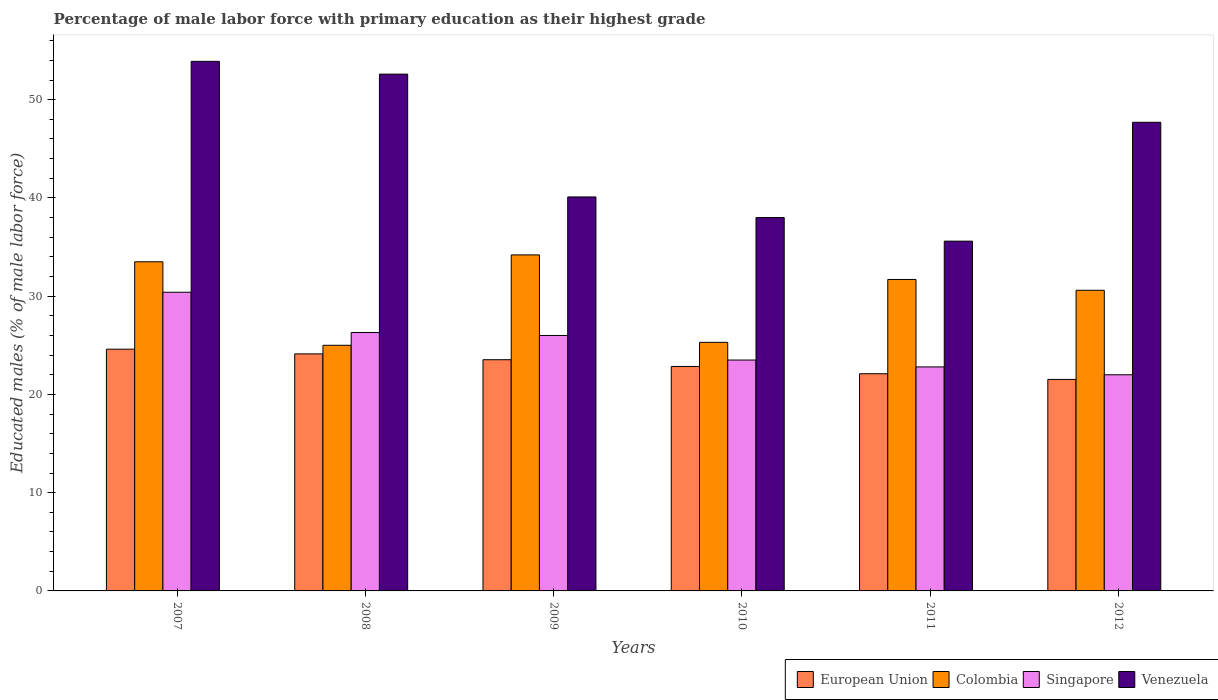How many different coloured bars are there?
Keep it short and to the point. 4. Are the number of bars per tick equal to the number of legend labels?
Give a very brief answer. Yes. Are the number of bars on each tick of the X-axis equal?
Your response must be concise. Yes. In how many cases, is the number of bars for a given year not equal to the number of legend labels?
Your answer should be very brief. 0. What is the percentage of male labor force with primary education in European Union in 2012?
Your answer should be very brief. 21.53. Across all years, what is the maximum percentage of male labor force with primary education in Singapore?
Your answer should be compact. 30.4. In which year was the percentage of male labor force with primary education in Colombia maximum?
Ensure brevity in your answer.  2009. In which year was the percentage of male labor force with primary education in European Union minimum?
Your response must be concise. 2012. What is the total percentage of male labor force with primary education in Venezuela in the graph?
Offer a terse response. 267.9. What is the difference between the percentage of male labor force with primary education in Colombia in 2008 and the percentage of male labor force with primary education in Venezuela in 2012?
Your response must be concise. -22.7. What is the average percentage of male labor force with primary education in Colombia per year?
Your answer should be compact. 30.05. In the year 2008, what is the difference between the percentage of male labor force with primary education in Venezuela and percentage of male labor force with primary education in European Union?
Give a very brief answer. 28.47. In how many years, is the percentage of male labor force with primary education in Singapore greater than 40 %?
Your answer should be very brief. 0. What is the ratio of the percentage of male labor force with primary education in Singapore in 2007 to that in 2012?
Offer a very short reply. 1.38. Is the percentage of male labor force with primary education in Singapore in 2010 less than that in 2012?
Make the answer very short. No. What is the difference between the highest and the second highest percentage of male labor force with primary education in European Union?
Provide a succinct answer. 0.48. What is the difference between the highest and the lowest percentage of male labor force with primary education in Venezuela?
Make the answer very short. 18.3. In how many years, is the percentage of male labor force with primary education in European Union greater than the average percentage of male labor force with primary education in European Union taken over all years?
Your answer should be very brief. 3. What does the 4th bar from the left in 2007 represents?
Provide a short and direct response. Venezuela. What does the 1st bar from the right in 2009 represents?
Provide a short and direct response. Venezuela. Does the graph contain any zero values?
Ensure brevity in your answer.  No. Where does the legend appear in the graph?
Keep it short and to the point. Bottom right. What is the title of the graph?
Make the answer very short. Percentage of male labor force with primary education as their highest grade. Does "Grenada" appear as one of the legend labels in the graph?
Your answer should be very brief. No. What is the label or title of the X-axis?
Offer a terse response. Years. What is the label or title of the Y-axis?
Provide a short and direct response. Educated males (% of male labor force). What is the Educated males (% of male labor force) of European Union in 2007?
Keep it short and to the point. 24.61. What is the Educated males (% of male labor force) in Colombia in 2007?
Keep it short and to the point. 33.5. What is the Educated males (% of male labor force) of Singapore in 2007?
Your answer should be compact. 30.4. What is the Educated males (% of male labor force) in Venezuela in 2007?
Keep it short and to the point. 53.9. What is the Educated males (% of male labor force) in European Union in 2008?
Keep it short and to the point. 24.13. What is the Educated males (% of male labor force) of Colombia in 2008?
Provide a short and direct response. 25. What is the Educated males (% of male labor force) in Singapore in 2008?
Offer a very short reply. 26.3. What is the Educated males (% of male labor force) of Venezuela in 2008?
Keep it short and to the point. 52.6. What is the Educated males (% of male labor force) in European Union in 2009?
Provide a succinct answer. 23.53. What is the Educated males (% of male labor force) in Colombia in 2009?
Provide a succinct answer. 34.2. What is the Educated males (% of male labor force) of Venezuela in 2009?
Your response must be concise. 40.1. What is the Educated males (% of male labor force) of European Union in 2010?
Make the answer very short. 22.85. What is the Educated males (% of male labor force) in Colombia in 2010?
Ensure brevity in your answer.  25.3. What is the Educated males (% of male labor force) in European Union in 2011?
Your response must be concise. 22.11. What is the Educated males (% of male labor force) of Colombia in 2011?
Provide a short and direct response. 31.7. What is the Educated males (% of male labor force) in Singapore in 2011?
Offer a terse response. 22.8. What is the Educated males (% of male labor force) in Venezuela in 2011?
Your answer should be very brief. 35.6. What is the Educated males (% of male labor force) in European Union in 2012?
Ensure brevity in your answer.  21.53. What is the Educated males (% of male labor force) of Colombia in 2012?
Offer a very short reply. 30.6. What is the Educated males (% of male labor force) of Singapore in 2012?
Your answer should be very brief. 22. What is the Educated males (% of male labor force) in Venezuela in 2012?
Your response must be concise. 47.7. Across all years, what is the maximum Educated males (% of male labor force) in European Union?
Your response must be concise. 24.61. Across all years, what is the maximum Educated males (% of male labor force) of Colombia?
Provide a short and direct response. 34.2. Across all years, what is the maximum Educated males (% of male labor force) of Singapore?
Keep it short and to the point. 30.4. Across all years, what is the maximum Educated males (% of male labor force) in Venezuela?
Offer a terse response. 53.9. Across all years, what is the minimum Educated males (% of male labor force) in European Union?
Your answer should be very brief. 21.53. Across all years, what is the minimum Educated males (% of male labor force) of Colombia?
Provide a succinct answer. 25. Across all years, what is the minimum Educated males (% of male labor force) of Singapore?
Your answer should be compact. 22. Across all years, what is the minimum Educated males (% of male labor force) of Venezuela?
Keep it short and to the point. 35.6. What is the total Educated males (% of male labor force) in European Union in the graph?
Your answer should be compact. 138.74. What is the total Educated males (% of male labor force) in Colombia in the graph?
Your response must be concise. 180.3. What is the total Educated males (% of male labor force) in Singapore in the graph?
Your answer should be compact. 151. What is the total Educated males (% of male labor force) of Venezuela in the graph?
Provide a succinct answer. 267.9. What is the difference between the Educated males (% of male labor force) in European Union in 2007 and that in 2008?
Give a very brief answer. 0.48. What is the difference between the Educated males (% of male labor force) of Singapore in 2007 and that in 2008?
Your answer should be very brief. 4.1. What is the difference between the Educated males (% of male labor force) in Venezuela in 2007 and that in 2008?
Offer a very short reply. 1.3. What is the difference between the Educated males (% of male labor force) of European Union in 2007 and that in 2009?
Offer a terse response. 1.07. What is the difference between the Educated males (% of male labor force) in Colombia in 2007 and that in 2009?
Your answer should be compact. -0.7. What is the difference between the Educated males (% of male labor force) of Venezuela in 2007 and that in 2009?
Provide a short and direct response. 13.8. What is the difference between the Educated males (% of male labor force) in European Union in 2007 and that in 2010?
Your answer should be very brief. 1.76. What is the difference between the Educated males (% of male labor force) of Colombia in 2007 and that in 2010?
Keep it short and to the point. 8.2. What is the difference between the Educated males (% of male labor force) in Venezuela in 2007 and that in 2010?
Your answer should be very brief. 15.9. What is the difference between the Educated males (% of male labor force) in European Union in 2007 and that in 2011?
Ensure brevity in your answer.  2.5. What is the difference between the Educated males (% of male labor force) in Singapore in 2007 and that in 2011?
Offer a very short reply. 7.6. What is the difference between the Educated males (% of male labor force) of European Union in 2007 and that in 2012?
Offer a very short reply. 3.08. What is the difference between the Educated males (% of male labor force) in Singapore in 2007 and that in 2012?
Keep it short and to the point. 8.4. What is the difference between the Educated males (% of male labor force) of Venezuela in 2007 and that in 2012?
Offer a very short reply. 6.2. What is the difference between the Educated males (% of male labor force) of European Union in 2008 and that in 2009?
Ensure brevity in your answer.  0.59. What is the difference between the Educated males (% of male labor force) in Colombia in 2008 and that in 2009?
Ensure brevity in your answer.  -9.2. What is the difference between the Educated males (% of male labor force) in Singapore in 2008 and that in 2009?
Provide a succinct answer. 0.3. What is the difference between the Educated males (% of male labor force) of European Union in 2008 and that in 2010?
Offer a terse response. 1.28. What is the difference between the Educated males (% of male labor force) in Singapore in 2008 and that in 2010?
Your response must be concise. 2.8. What is the difference between the Educated males (% of male labor force) in European Union in 2008 and that in 2011?
Provide a succinct answer. 2.02. What is the difference between the Educated males (% of male labor force) in Colombia in 2008 and that in 2011?
Your response must be concise. -6.7. What is the difference between the Educated males (% of male labor force) of Venezuela in 2008 and that in 2011?
Offer a terse response. 17. What is the difference between the Educated males (% of male labor force) in European Union in 2008 and that in 2012?
Ensure brevity in your answer.  2.6. What is the difference between the Educated males (% of male labor force) of Singapore in 2008 and that in 2012?
Ensure brevity in your answer.  4.3. What is the difference between the Educated males (% of male labor force) in Venezuela in 2008 and that in 2012?
Make the answer very short. 4.9. What is the difference between the Educated males (% of male labor force) of European Union in 2009 and that in 2010?
Your answer should be compact. 0.69. What is the difference between the Educated males (% of male labor force) of Singapore in 2009 and that in 2010?
Provide a short and direct response. 2.5. What is the difference between the Educated males (% of male labor force) in Venezuela in 2009 and that in 2010?
Offer a terse response. 2.1. What is the difference between the Educated males (% of male labor force) of European Union in 2009 and that in 2011?
Your response must be concise. 1.43. What is the difference between the Educated males (% of male labor force) of Singapore in 2009 and that in 2011?
Give a very brief answer. 3.2. What is the difference between the Educated males (% of male labor force) in Venezuela in 2009 and that in 2011?
Your answer should be compact. 4.5. What is the difference between the Educated males (% of male labor force) in European Union in 2009 and that in 2012?
Ensure brevity in your answer.  2.01. What is the difference between the Educated males (% of male labor force) of Colombia in 2009 and that in 2012?
Provide a short and direct response. 3.6. What is the difference between the Educated males (% of male labor force) of Venezuela in 2009 and that in 2012?
Offer a very short reply. -7.6. What is the difference between the Educated males (% of male labor force) in European Union in 2010 and that in 2011?
Give a very brief answer. 0.74. What is the difference between the Educated males (% of male labor force) of Singapore in 2010 and that in 2011?
Offer a terse response. 0.7. What is the difference between the Educated males (% of male labor force) of European Union in 2010 and that in 2012?
Make the answer very short. 1.32. What is the difference between the Educated males (% of male labor force) of Colombia in 2010 and that in 2012?
Give a very brief answer. -5.3. What is the difference between the Educated males (% of male labor force) in Singapore in 2010 and that in 2012?
Give a very brief answer. 1.5. What is the difference between the Educated males (% of male labor force) of Venezuela in 2010 and that in 2012?
Offer a very short reply. -9.7. What is the difference between the Educated males (% of male labor force) in European Union in 2011 and that in 2012?
Ensure brevity in your answer.  0.58. What is the difference between the Educated males (% of male labor force) of European Union in 2007 and the Educated males (% of male labor force) of Colombia in 2008?
Ensure brevity in your answer.  -0.39. What is the difference between the Educated males (% of male labor force) in European Union in 2007 and the Educated males (% of male labor force) in Singapore in 2008?
Provide a short and direct response. -1.69. What is the difference between the Educated males (% of male labor force) in European Union in 2007 and the Educated males (% of male labor force) in Venezuela in 2008?
Your answer should be very brief. -27.99. What is the difference between the Educated males (% of male labor force) in Colombia in 2007 and the Educated males (% of male labor force) in Venezuela in 2008?
Provide a succinct answer. -19.1. What is the difference between the Educated males (% of male labor force) in Singapore in 2007 and the Educated males (% of male labor force) in Venezuela in 2008?
Your answer should be compact. -22.2. What is the difference between the Educated males (% of male labor force) of European Union in 2007 and the Educated males (% of male labor force) of Colombia in 2009?
Your answer should be compact. -9.59. What is the difference between the Educated males (% of male labor force) of European Union in 2007 and the Educated males (% of male labor force) of Singapore in 2009?
Keep it short and to the point. -1.39. What is the difference between the Educated males (% of male labor force) in European Union in 2007 and the Educated males (% of male labor force) in Venezuela in 2009?
Offer a very short reply. -15.49. What is the difference between the Educated males (% of male labor force) of Colombia in 2007 and the Educated males (% of male labor force) of Venezuela in 2009?
Your answer should be very brief. -6.6. What is the difference between the Educated males (% of male labor force) in Singapore in 2007 and the Educated males (% of male labor force) in Venezuela in 2009?
Offer a very short reply. -9.7. What is the difference between the Educated males (% of male labor force) of European Union in 2007 and the Educated males (% of male labor force) of Colombia in 2010?
Provide a short and direct response. -0.69. What is the difference between the Educated males (% of male labor force) of European Union in 2007 and the Educated males (% of male labor force) of Singapore in 2010?
Ensure brevity in your answer.  1.11. What is the difference between the Educated males (% of male labor force) of European Union in 2007 and the Educated males (% of male labor force) of Venezuela in 2010?
Offer a terse response. -13.39. What is the difference between the Educated males (% of male labor force) of Colombia in 2007 and the Educated males (% of male labor force) of Singapore in 2010?
Provide a succinct answer. 10. What is the difference between the Educated males (% of male labor force) in Colombia in 2007 and the Educated males (% of male labor force) in Venezuela in 2010?
Provide a short and direct response. -4.5. What is the difference between the Educated males (% of male labor force) in European Union in 2007 and the Educated males (% of male labor force) in Colombia in 2011?
Your answer should be compact. -7.09. What is the difference between the Educated males (% of male labor force) in European Union in 2007 and the Educated males (% of male labor force) in Singapore in 2011?
Your answer should be compact. 1.81. What is the difference between the Educated males (% of male labor force) of European Union in 2007 and the Educated males (% of male labor force) of Venezuela in 2011?
Your answer should be compact. -10.99. What is the difference between the Educated males (% of male labor force) of Colombia in 2007 and the Educated males (% of male labor force) of Singapore in 2011?
Give a very brief answer. 10.7. What is the difference between the Educated males (% of male labor force) in Colombia in 2007 and the Educated males (% of male labor force) in Venezuela in 2011?
Ensure brevity in your answer.  -2.1. What is the difference between the Educated males (% of male labor force) in Singapore in 2007 and the Educated males (% of male labor force) in Venezuela in 2011?
Ensure brevity in your answer.  -5.2. What is the difference between the Educated males (% of male labor force) of European Union in 2007 and the Educated males (% of male labor force) of Colombia in 2012?
Ensure brevity in your answer.  -5.99. What is the difference between the Educated males (% of male labor force) of European Union in 2007 and the Educated males (% of male labor force) of Singapore in 2012?
Your answer should be very brief. 2.61. What is the difference between the Educated males (% of male labor force) of European Union in 2007 and the Educated males (% of male labor force) of Venezuela in 2012?
Provide a succinct answer. -23.09. What is the difference between the Educated males (% of male labor force) of Colombia in 2007 and the Educated males (% of male labor force) of Singapore in 2012?
Provide a short and direct response. 11.5. What is the difference between the Educated males (% of male labor force) in Colombia in 2007 and the Educated males (% of male labor force) in Venezuela in 2012?
Provide a short and direct response. -14.2. What is the difference between the Educated males (% of male labor force) in Singapore in 2007 and the Educated males (% of male labor force) in Venezuela in 2012?
Provide a short and direct response. -17.3. What is the difference between the Educated males (% of male labor force) of European Union in 2008 and the Educated males (% of male labor force) of Colombia in 2009?
Keep it short and to the point. -10.07. What is the difference between the Educated males (% of male labor force) in European Union in 2008 and the Educated males (% of male labor force) in Singapore in 2009?
Ensure brevity in your answer.  -1.87. What is the difference between the Educated males (% of male labor force) of European Union in 2008 and the Educated males (% of male labor force) of Venezuela in 2009?
Ensure brevity in your answer.  -15.97. What is the difference between the Educated males (% of male labor force) of Colombia in 2008 and the Educated males (% of male labor force) of Venezuela in 2009?
Make the answer very short. -15.1. What is the difference between the Educated males (% of male labor force) in European Union in 2008 and the Educated males (% of male labor force) in Colombia in 2010?
Give a very brief answer. -1.17. What is the difference between the Educated males (% of male labor force) of European Union in 2008 and the Educated males (% of male labor force) of Singapore in 2010?
Offer a terse response. 0.63. What is the difference between the Educated males (% of male labor force) in European Union in 2008 and the Educated males (% of male labor force) in Venezuela in 2010?
Your answer should be compact. -13.87. What is the difference between the Educated males (% of male labor force) of Colombia in 2008 and the Educated males (% of male labor force) of Singapore in 2010?
Provide a succinct answer. 1.5. What is the difference between the Educated males (% of male labor force) of Singapore in 2008 and the Educated males (% of male labor force) of Venezuela in 2010?
Give a very brief answer. -11.7. What is the difference between the Educated males (% of male labor force) in European Union in 2008 and the Educated males (% of male labor force) in Colombia in 2011?
Your answer should be very brief. -7.57. What is the difference between the Educated males (% of male labor force) in European Union in 2008 and the Educated males (% of male labor force) in Singapore in 2011?
Your answer should be compact. 1.33. What is the difference between the Educated males (% of male labor force) in European Union in 2008 and the Educated males (% of male labor force) in Venezuela in 2011?
Your answer should be compact. -11.47. What is the difference between the Educated males (% of male labor force) of Colombia in 2008 and the Educated males (% of male labor force) of Singapore in 2011?
Provide a short and direct response. 2.2. What is the difference between the Educated males (% of male labor force) of Singapore in 2008 and the Educated males (% of male labor force) of Venezuela in 2011?
Your answer should be very brief. -9.3. What is the difference between the Educated males (% of male labor force) in European Union in 2008 and the Educated males (% of male labor force) in Colombia in 2012?
Your answer should be very brief. -6.47. What is the difference between the Educated males (% of male labor force) in European Union in 2008 and the Educated males (% of male labor force) in Singapore in 2012?
Ensure brevity in your answer.  2.13. What is the difference between the Educated males (% of male labor force) in European Union in 2008 and the Educated males (% of male labor force) in Venezuela in 2012?
Make the answer very short. -23.57. What is the difference between the Educated males (% of male labor force) in Colombia in 2008 and the Educated males (% of male labor force) in Venezuela in 2012?
Offer a terse response. -22.7. What is the difference between the Educated males (% of male labor force) in Singapore in 2008 and the Educated males (% of male labor force) in Venezuela in 2012?
Your answer should be compact. -21.4. What is the difference between the Educated males (% of male labor force) in European Union in 2009 and the Educated males (% of male labor force) in Colombia in 2010?
Provide a succinct answer. -1.77. What is the difference between the Educated males (% of male labor force) in European Union in 2009 and the Educated males (% of male labor force) in Singapore in 2010?
Provide a succinct answer. 0.03. What is the difference between the Educated males (% of male labor force) in European Union in 2009 and the Educated males (% of male labor force) in Venezuela in 2010?
Ensure brevity in your answer.  -14.47. What is the difference between the Educated males (% of male labor force) of European Union in 2009 and the Educated males (% of male labor force) of Colombia in 2011?
Ensure brevity in your answer.  -8.17. What is the difference between the Educated males (% of male labor force) in European Union in 2009 and the Educated males (% of male labor force) in Singapore in 2011?
Keep it short and to the point. 0.73. What is the difference between the Educated males (% of male labor force) in European Union in 2009 and the Educated males (% of male labor force) in Venezuela in 2011?
Make the answer very short. -12.07. What is the difference between the Educated males (% of male labor force) of Colombia in 2009 and the Educated males (% of male labor force) of Singapore in 2011?
Offer a very short reply. 11.4. What is the difference between the Educated males (% of male labor force) in Colombia in 2009 and the Educated males (% of male labor force) in Venezuela in 2011?
Your answer should be very brief. -1.4. What is the difference between the Educated males (% of male labor force) of European Union in 2009 and the Educated males (% of male labor force) of Colombia in 2012?
Offer a terse response. -7.07. What is the difference between the Educated males (% of male labor force) of European Union in 2009 and the Educated males (% of male labor force) of Singapore in 2012?
Ensure brevity in your answer.  1.53. What is the difference between the Educated males (% of male labor force) of European Union in 2009 and the Educated males (% of male labor force) of Venezuela in 2012?
Your answer should be very brief. -24.17. What is the difference between the Educated males (% of male labor force) of Colombia in 2009 and the Educated males (% of male labor force) of Singapore in 2012?
Offer a very short reply. 12.2. What is the difference between the Educated males (% of male labor force) in Colombia in 2009 and the Educated males (% of male labor force) in Venezuela in 2012?
Your answer should be compact. -13.5. What is the difference between the Educated males (% of male labor force) of Singapore in 2009 and the Educated males (% of male labor force) of Venezuela in 2012?
Offer a very short reply. -21.7. What is the difference between the Educated males (% of male labor force) in European Union in 2010 and the Educated males (% of male labor force) in Colombia in 2011?
Your response must be concise. -8.85. What is the difference between the Educated males (% of male labor force) of European Union in 2010 and the Educated males (% of male labor force) of Singapore in 2011?
Offer a terse response. 0.05. What is the difference between the Educated males (% of male labor force) in European Union in 2010 and the Educated males (% of male labor force) in Venezuela in 2011?
Give a very brief answer. -12.75. What is the difference between the Educated males (% of male labor force) in Colombia in 2010 and the Educated males (% of male labor force) in Singapore in 2011?
Give a very brief answer. 2.5. What is the difference between the Educated males (% of male labor force) in Colombia in 2010 and the Educated males (% of male labor force) in Venezuela in 2011?
Make the answer very short. -10.3. What is the difference between the Educated males (% of male labor force) in Singapore in 2010 and the Educated males (% of male labor force) in Venezuela in 2011?
Provide a succinct answer. -12.1. What is the difference between the Educated males (% of male labor force) of European Union in 2010 and the Educated males (% of male labor force) of Colombia in 2012?
Offer a very short reply. -7.75. What is the difference between the Educated males (% of male labor force) of European Union in 2010 and the Educated males (% of male labor force) of Singapore in 2012?
Your answer should be very brief. 0.85. What is the difference between the Educated males (% of male labor force) in European Union in 2010 and the Educated males (% of male labor force) in Venezuela in 2012?
Your answer should be very brief. -24.85. What is the difference between the Educated males (% of male labor force) of Colombia in 2010 and the Educated males (% of male labor force) of Venezuela in 2012?
Your response must be concise. -22.4. What is the difference between the Educated males (% of male labor force) in Singapore in 2010 and the Educated males (% of male labor force) in Venezuela in 2012?
Your response must be concise. -24.2. What is the difference between the Educated males (% of male labor force) in European Union in 2011 and the Educated males (% of male labor force) in Colombia in 2012?
Offer a terse response. -8.49. What is the difference between the Educated males (% of male labor force) in European Union in 2011 and the Educated males (% of male labor force) in Singapore in 2012?
Ensure brevity in your answer.  0.11. What is the difference between the Educated males (% of male labor force) in European Union in 2011 and the Educated males (% of male labor force) in Venezuela in 2012?
Provide a succinct answer. -25.59. What is the difference between the Educated males (% of male labor force) in Colombia in 2011 and the Educated males (% of male labor force) in Venezuela in 2012?
Provide a succinct answer. -16. What is the difference between the Educated males (% of male labor force) of Singapore in 2011 and the Educated males (% of male labor force) of Venezuela in 2012?
Your answer should be very brief. -24.9. What is the average Educated males (% of male labor force) of European Union per year?
Provide a short and direct response. 23.12. What is the average Educated males (% of male labor force) of Colombia per year?
Give a very brief answer. 30.05. What is the average Educated males (% of male labor force) of Singapore per year?
Give a very brief answer. 25.17. What is the average Educated males (% of male labor force) of Venezuela per year?
Provide a succinct answer. 44.65. In the year 2007, what is the difference between the Educated males (% of male labor force) in European Union and Educated males (% of male labor force) in Colombia?
Give a very brief answer. -8.89. In the year 2007, what is the difference between the Educated males (% of male labor force) in European Union and Educated males (% of male labor force) in Singapore?
Keep it short and to the point. -5.79. In the year 2007, what is the difference between the Educated males (% of male labor force) in European Union and Educated males (% of male labor force) in Venezuela?
Give a very brief answer. -29.29. In the year 2007, what is the difference between the Educated males (% of male labor force) in Colombia and Educated males (% of male labor force) in Venezuela?
Provide a succinct answer. -20.4. In the year 2007, what is the difference between the Educated males (% of male labor force) in Singapore and Educated males (% of male labor force) in Venezuela?
Give a very brief answer. -23.5. In the year 2008, what is the difference between the Educated males (% of male labor force) of European Union and Educated males (% of male labor force) of Colombia?
Offer a very short reply. -0.87. In the year 2008, what is the difference between the Educated males (% of male labor force) of European Union and Educated males (% of male labor force) of Singapore?
Your answer should be compact. -2.17. In the year 2008, what is the difference between the Educated males (% of male labor force) in European Union and Educated males (% of male labor force) in Venezuela?
Your answer should be very brief. -28.47. In the year 2008, what is the difference between the Educated males (% of male labor force) in Colombia and Educated males (% of male labor force) in Venezuela?
Keep it short and to the point. -27.6. In the year 2008, what is the difference between the Educated males (% of male labor force) of Singapore and Educated males (% of male labor force) of Venezuela?
Make the answer very short. -26.3. In the year 2009, what is the difference between the Educated males (% of male labor force) of European Union and Educated males (% of male labor force) of Colombia?
Provide a succinct answer. -10.67. In the year 2009, what is the difference between the Educated males (% of male labor force) of European Union and Educated males (% of male labor force) of Singapore?
Your response must be concise. -2.47. In the year 2009, what is the difference between the Educated males (% of male labor force) in European Union and Educated males (% of male labor force) in Venezuela?
Keep it short and to the point. -16.57. In the year 2009, what is the difference between the Educated males (% of male labor force) of Colombia and Educated males (% of male labor force) of Singapore?
Offer a terse response. 8.2. In the year 2009, what is the difference between the Educated males (% of male labor force) of Colombia and Educated males (% of male labor force) of Venezuela?
Offer a terse response. -5.9. In the year 2009, what is the difference between the Educated males (% of male labor force) of Singapore and Educated males (% of male labor force) of Venezuela?
Ensure brevity in your answer.  -14.1. In the year 2010, what is the difference between the Educated males (% of male labor force) in European Union and Educated males (% of male labor force) in Colombia?
Provide a succinct answer. -2.45. In the year 2010, what is the difference between the Educated males (% of male labor force) of European Union and Educated males (% of male labor force) of Singapore?
Ensure brevity in your answer.  -0.65. In the year 2010, what is the difference between the Educated males (% of male labor force) in European Union and Educated males (% of male labor force) in Venezuela?
Make the answer very short. -15.15. In the year 2010, what is the difference between the Educated males (% of male labor force) in Colombia and Educated males (% of male labor force) in Singapore?
Offer a very short reply. 1.8. In the year 2011, what is the difference between the Educated males (% of male labor force) in European Union and Educated males (% of male labor force) in Colombia?
Your response must be concise. -9.59. In the year 2011, what is the difference between the Educated males (% of male labor force) of European Union and Educated males (% of male labor force) of Singapore?
Your answer should be compact. -0.69. In the year 2011, what is the difference between the Educated males (% of male labor force) in European Union and Educated males (% of male labor force) in Venezuela?
Make the answer very short. -13.49. In the year 2011, what is the difference between the Educated males (% of male labor force) in Colombia and Educated males (% of male labor force) in Venezuela?
Offer a terse response. -3.9. In the year 2012, what is the difference between the Educated males (% of male labor force) in European Union and Educated males (% of male labor force) in Colombia?
Your response must be concise. -9.07. In the year 2012, what is the difference between the Educated males (% of male labor force) in European Union and Educated males (% of male labor force) in Singapore?
Offer a very short reply. -0.47. In the year 2012, what is the difference between the Educated males (% of male labor force) of European Union and Educated males (% of male labor force) of Venezuela?
Make the answer very short. -26.17. In the year 2012, what is the difference between the Educated males (% of male labor force) in Colombia and Educated males (% of male labor force) in Singapore?
Provide a short and direct response. 8.6. In the year 2012, what is the difference between the Educated males (% of male labor force) in Colombia and Educated males (% of male labor force) in Venezuela?
Provide a short and direct response. -17.1. In the year 2012, what is the difference between the Educated males (% of male labor force) of Singapore and Educated males (% of male labor force) of Venezuela?
Offer a terse response. -25.7. What is the ratio of the Educated males (% of male labor force) in European Union in 2007 to that in 2008?
Give a very brief answer. 1.02. What is the ratio of the Educated males (% of male labor force) in Colombia in 2007 to that in 2008?
Offer a very short reply. 1.34. What is the ratio of the Educated males (% of male labor force) of Singapore in 2007 to that in 2008?
Provide a succinct answer. 1.16. What is the ratio of the Educated males (% of male labor force) in Venezuela in 2007 to that in 2008?
Provide a succinct answer. 1.02. What is the ratio of the Educated males (% of male labor force) in European Union in 2007 to that in 2009?
Offer a very short reply. 1.05. What is the ratio of the Educated males (% of male labor force) in Colombia in 2007 to that in 2009?
Offer a terse response. 0.98. What is the ratio of the Educated males (% of male labor force) of Singapore in 2007 to that in 2009?
Offer a very short reply. 1.17. What is the ratio of the Educated males (% of male labor force) of Venezuela in 2007 to that in 2009?
Make the answer very short. 1.34. What is the ratio of the Educated males (% of male labor force) of European Union in 2007 to that in 2010?
Your answer should be compact. 1.08. What is the ratio of the Educated males (% of male labor force) of Colombia in 2007 to that in 2010?
Offer a terse response. 1.32. What is the ratio of the Educated males (% of male labor force) in Singapore in 2007 to that in 2010?
Offer a terse response. 1.29. What is the ratio of the Educated males (% of male labor force) of Venezuela in 2007 to that in 2010?
Offer a very short reply. 1.42. What is the ratio of the Educated males (% of male labor force) of European Union in 2007 to that in 2011?
Your response must be concise. 1.11. What is the ratio of the Educated males (% of male labor force) in Colombia in 2007 to that in 2011?
Keep it short and to the point. 1.06. What is the ratio of the Educated males (% of male labor force) in Venezuela in 2007 to that in 2011?
Your response must be concise. 1.51. What is the ratio of the Educated males (% of male labor force) in European Union in 2007 to that in 2012?
Keep it short and to the point. 1.14. What is the ratio of the Educated males (% of male labor force) of Colombia in 2007 to that in 2012?
Offer a very short reply. 1.09. What is the ratio of the Educated males (% of male labor force) of Singapore in 2007 to that in 2012?
Make the answer very short. 1.38. What is the ratio of the Educated males (% of male labor force) in Venezuela in 2007 to that in 2012?
Your answer should be compact. 1.13. What is the ratio of the Educated males (% of male labor force) of European Union in 2008 to that in 2009?
Offer a very short reply. 1.03. What is the ratio of the Educated males (% of male labor force) in Colombia in 2008 to that in 2009?
Provide a succinct answer. 0.73. What is the ratio of the Educated males (% of male labor force) of Singapore in 2008 to that in 2009?
Your response must be concise. 1.01. What is the ratio of the Educated males (% of male labor force) of Venezuela in 2008 to that in 2009?
Ensure brevity in your answer.  1.31. What is the ratio of the Educated males (% of male labor force) of European Union in 2008 to that in 2010?
Provide a short and direct response. 1.06. What is the ratio of the Educated males (% of male labor force) of Singapore in 2008 to that in 2010?
Your answer should be very brief. 1.12. What is the ratio of the Educated males (% of male labor force) of Venezuela in 2008 to that in 2010?
Offer a terse response. 1.38. What is the ratio of the Educated males (% of male labor force) in European Union in 2008 to that in 2011?
Provide a succinct answer. 1.09. What is the ratio of the Educated males (% of male labor force) of Colombia in 2008 to that in 2011?
Ensure brevity in your answer.  0.79. What is the ratio of the Educated males (% of male labor force) of Singapore in 2008 to that in 2011?
Provide a succinct answer. 1.15. What is the ratio of the Educated males (% of male labor force) of Venezuela in 2008 to that in 2011?
Provide a short and direct response. 1.48. What is the ratio of the Educated males (% of male labor force) in European Union in 2008 to that in 2012?
Offer a terse response. 1.12. What is the ratio of the Educated males (% of male labor force) in Colombia in 2008 to that in 2012?
Your answer should be compact. 0.82. What is the ratio of the Educated males (% of male labor force) in Singapore in 2008 to that in 2012?
Your answer should be very brief. 1.2. What is the ratio of the Educated males (% of male labor force) in Venezuela in 2008 to that in 2012?
Your response must be concise. 1.1. What is the ratio of the Educated males (% of male labor force) in European Union in 2009 to that in 2010?
Your answer should be very brief. 1.03. What is the ratio of the Educated males (% of male labor force) in Colombia in 2009 to that in 2010?
Your answer should be very brief. 1.35. What is the ratio of the Educated males (% of male labor force) of Singapore in 2009 to that in 2010?
Your answer should be very brief. 1.11. What is the ratio of the Educated males (% of male labor force) of Venezuela in 2009 to that in 2010?
Your answer should be compact. 1.06. What is the ratio of the Educated males (% of male labor force) of European Union in 2009 to that in 2011?
Provide a succinct answer. 1.06. What is the ratio of the Educated males (% of male labor force) in Colombia in 2009 to that in 2011?
Provide a succinct answer. 1.08. What is the ratio of the Educated males (% of male labor force) of Singapore in 2009 to that in 2011?
Make the answer very short. 1.14. What is the ratio of the Educated males (% of male labor force) of Venezuela in 2009 to that in 2011?
Ensure brevity in your answer.  1.13. What is the ratio of the Educated males (% of male labor force) in European Union in 2009 to that in 2012?
Your answer should be very brief. 1.09. What is the ratio of the Educated males (% of male labor force) in Colombia in 2009 to that in 2012?
Offer a terse response. 1.12. What is the ratio of the Educated males (% of male labor force) in Singapore in 2009 to that in 2012?
Provide a succinct answer. 1.18. What is the ratio of the Educated males (% of male labor force) of Venezuela in 2009 to that in 2012?
Make the answer very short. 0.84. What is the ratio of the Educated males (% of male labor force) of European Union in 2010 to that in 2011?
Provide a short and direct response. 1.03. What is the ratio of the Educated males (% of male labor force) of Colombia in 2010 to that in 2011?
Give a very brief answer. 0.8. What is the ratio of the Educated males (% of male labor force) in Singapore in 2010 to that in 2011?
Provide a short and direct response. 1.03. What is the ratio of the Educated males (% of male labor force) in Venezuela in 2010 to that in 2011?
Your answer should be compact. 1.07. What is the ratio of the Educated males (% of male labor force) of European Union in 2010 to that in 2012?
Provide a succinct answer. 1.06. What is the ratio of the Educated males (% of male labor force) of Colombia in 2010 to that in 2012?
Make the answer very short. 0.83. What is the ratio of the Educated males (% of male labor force) of Singapore in 2010 to that in 2012?
Give a very brief answer. 1.07. What is the ratio of the Educated males (% of male labor force) in Venezuela in 2010 to that in 2012?
Ensure brevity in your answer.  0.8. What is the ratio of the Educated males (% of male labor force) in European Union in 2011 to that in 2012?
Provide a short and direct response. 1.03. What is the ratio of the Educated males (% of male labor force) of Colombia in 2011 to that in 2012?
Offer a terse response. 1.04. What is the ratio of the Educated males (% of male labor force) in Singapore in 2011 to that in 2012?
Make the answer very short. 1.04. What is the ratio of the Educated males (% of male labor force) in Venezuela in 2011 to that in 2012?
Keep it short and to the point. 0.75. What is the difference between the highest and the second highest Educated males (% of male labor force) of European Union?
Your answer should be very brief. 0.48. What is the difference between the highest and the lowest Educated males (% of male labor force) in European Union?
Make the answer very short. 3.08. What is the difference between the highest and the lowest Educated males (% of male labor force) of Singapore?
Make the answer very short. 8.4. 